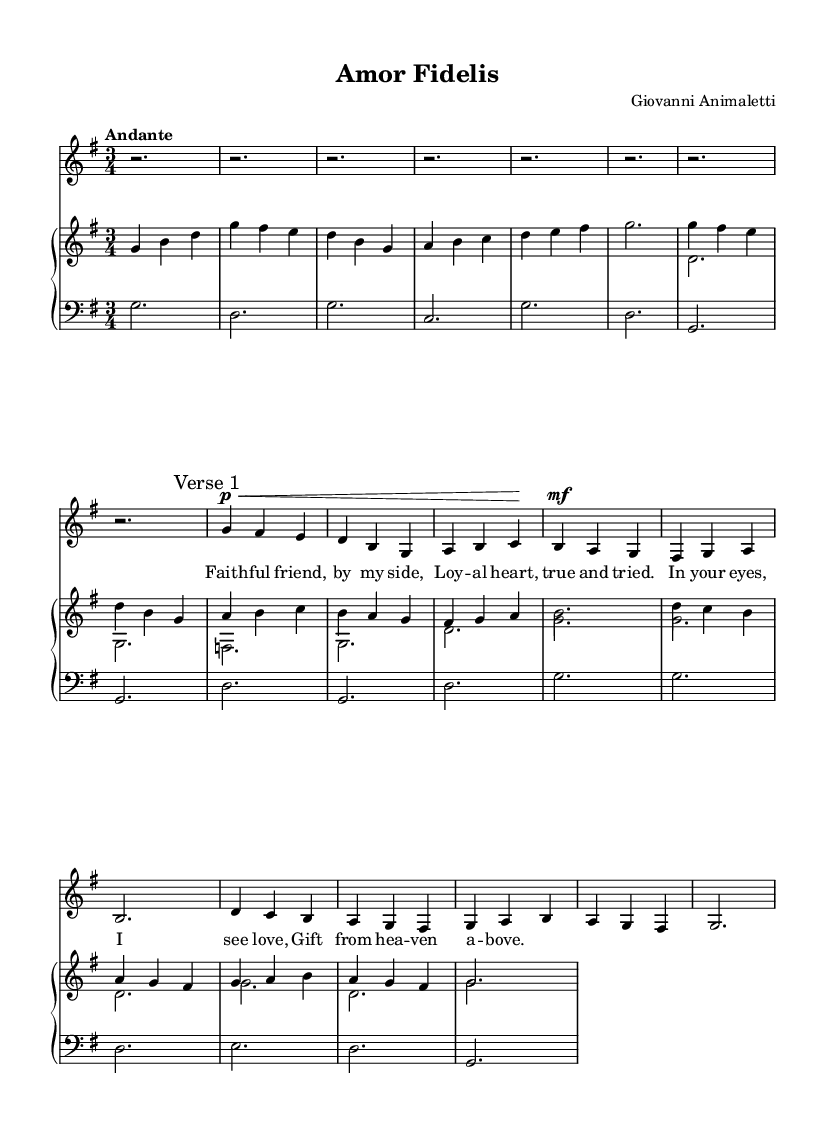What is the key signature of this music? The key signature shows one sharp, indicating that the piece is in G major.
Answer: G major What is the time signature of this music? The time signature appears at the beginning of the score as 3/4, indicating that there are three beats in each measure and a quarter note gets one beat.
Answer: 3/4 What is the tempo marking for this piece? The tempo marking is written above the staff as "Andante," which indicates a moderately slow tempo.
Answer: Andante How many verses are included in this section of the music? The music has a label "Verse 1," indicating that there is at least one verse provided, though the sheet does not indicate more than this one.
Answer: One What dynamic marking is indicated for the soprano part at the start of the verse? The dynamic marking shows "p<," indicating a soft sound that gradually becomes louder, typically denoted as "piano crescendo."
Answer: piano crescendo What type of musical form is observed in the aria? The aria follows a strophic form, as indicated by the repetition of the lyrical section labeled as "Verse 1."
Answer: Strophic What instrument accompanies the soprano in this aria? The accompaniment for the soprano is provided by a piano, as indicated by the notation for a "PianoStaff" in the score.
Answer: Piano 